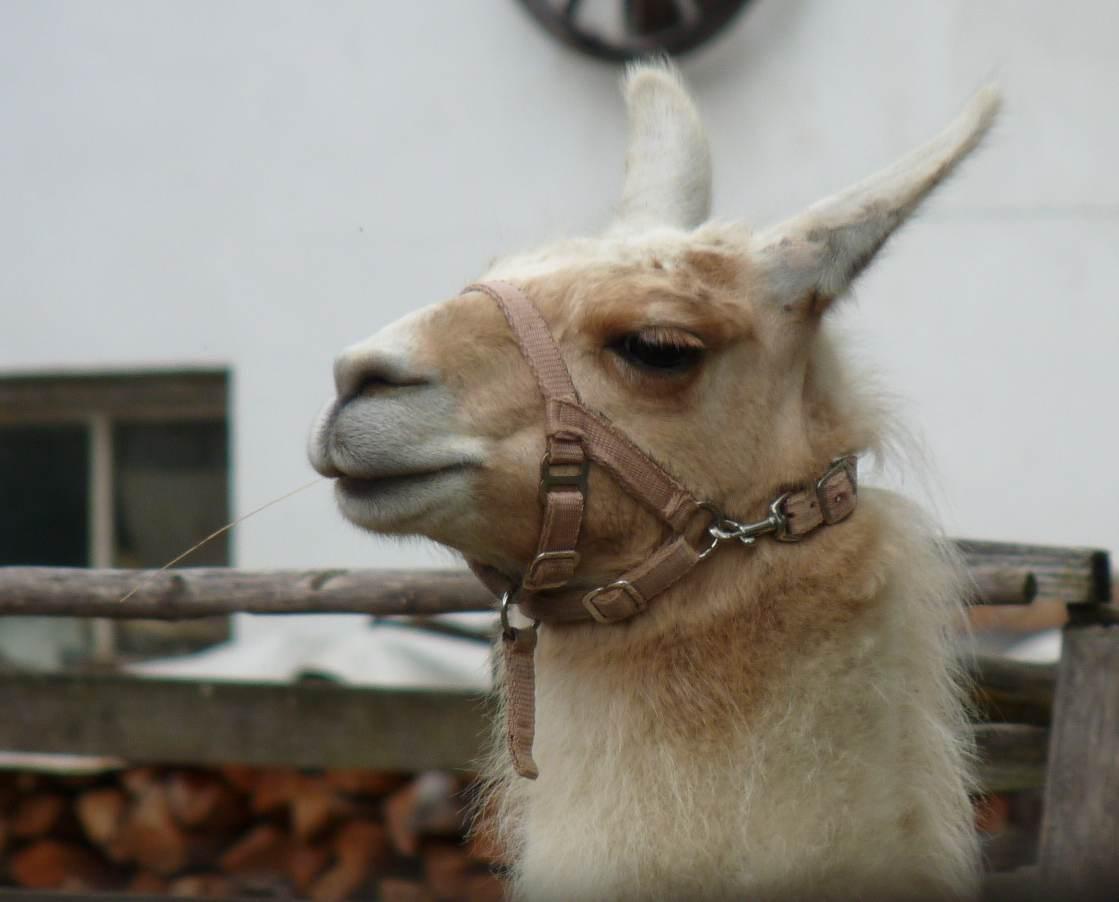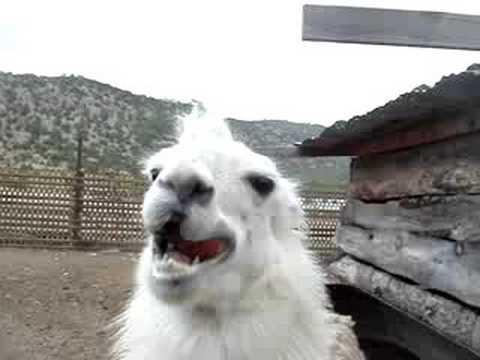The first image is the image on the left, the second image is the image on the right. Analyze the images presented: Is the assertion "In the right image, a pair of black-gloved hands are offering an apple to a white llama that is facing rightward." valid? Answer yes or no. No. The first image is the image on the left, the second image is the image on the right. Evaluate the accuracy of this statement regarding the images: "A llama is being fed an apple.". Is it true? Answer yes or no. No. 